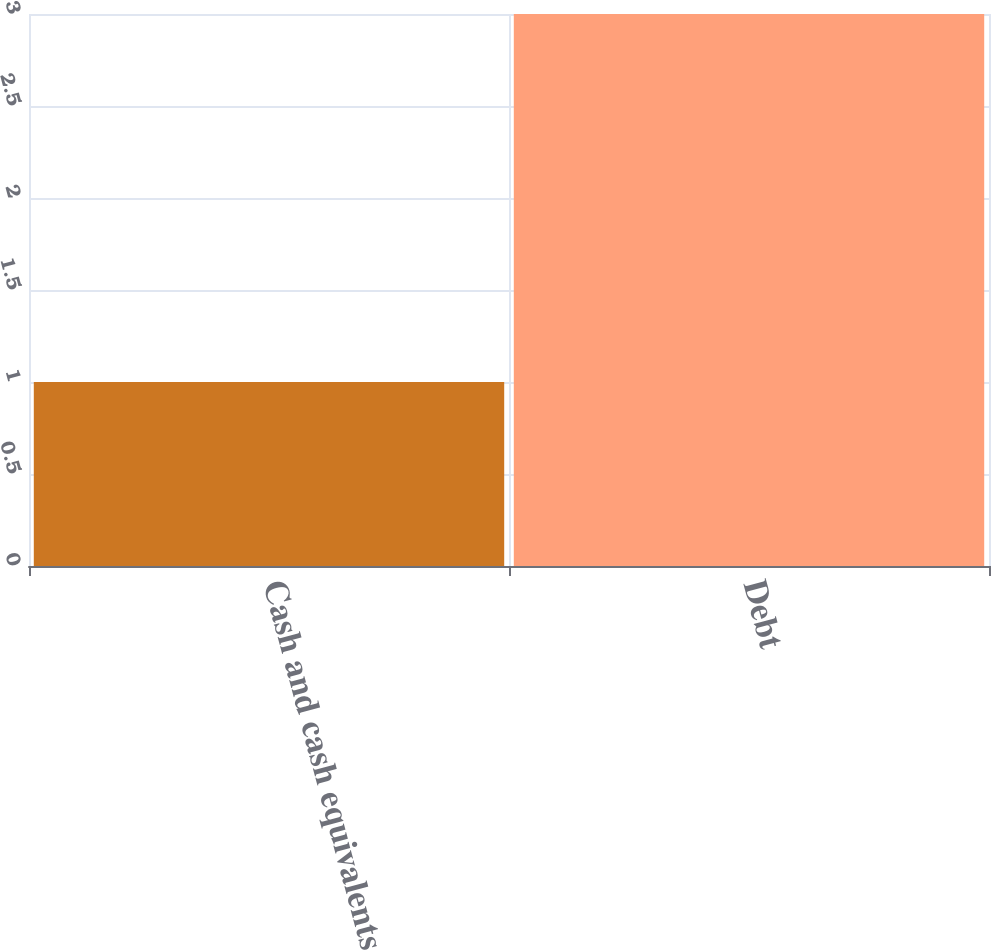<chart> <loc_0><loc_0><loc_500><loc_500><bar_chart><fcel>Cash and cash equivalents<fcel>Debt<nl><fcel>1<fcel>3<nl></chart> 